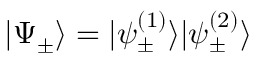Convert formula to latex. <formula><loc_0><loc_0><loc_500><loc_500>| \Psi _ { \pm } \rangle = | \psi _ { \pm } ^ { ( 1 ) } \rangle | \psi _ { \pm } ^ { ( 2 ) } \rangle</formula> 